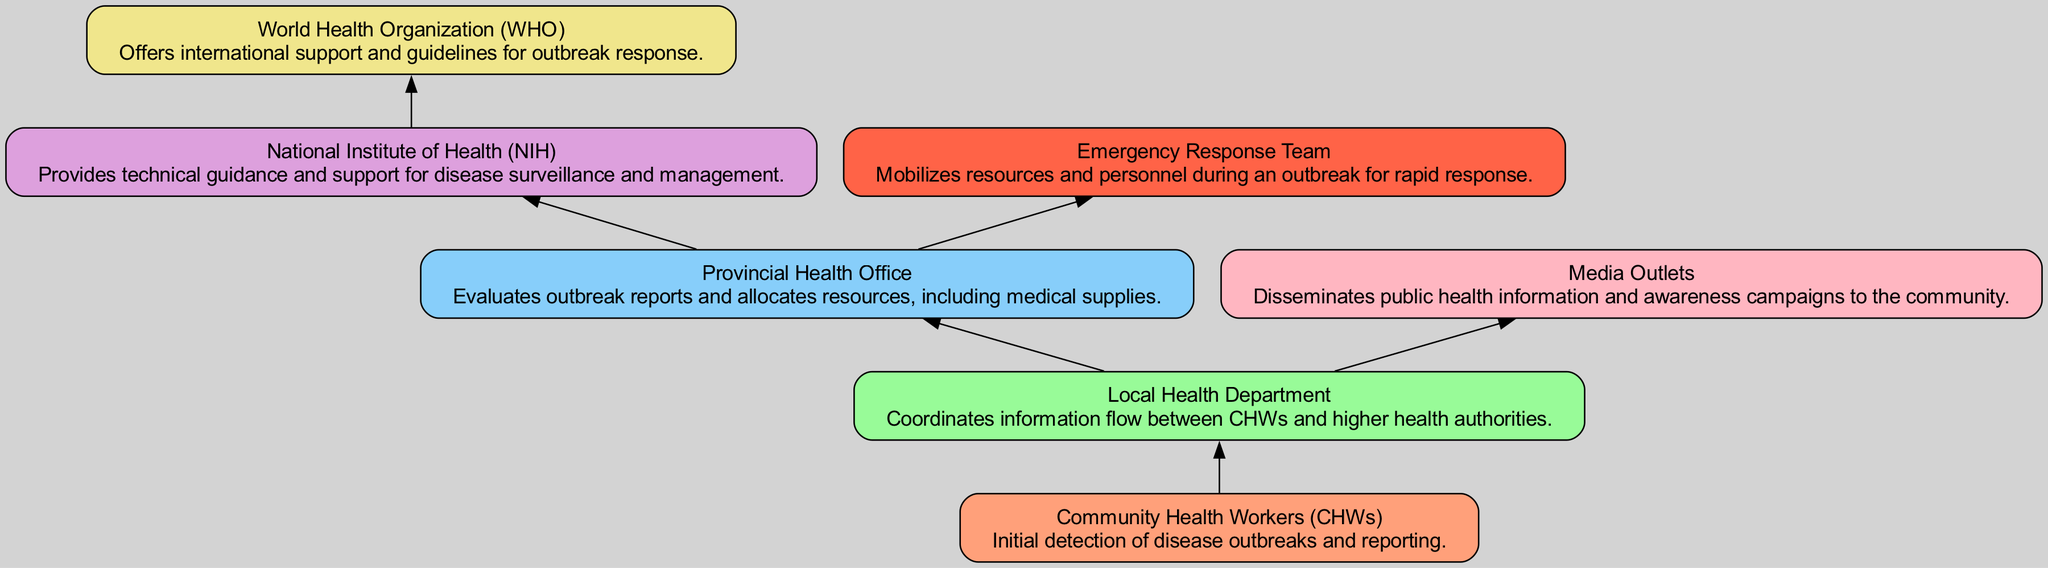What is the role of Community Health Workers (CHWs)? The diagram shows that Community Health Workers (CHWs) are responsible for the initial detection of disease outbreaks and reporting. Hence, their role is identified straightforwardly in their associated description.
Answer: Initial detection of disease outbreaks and reporting Which two entities are directly connected from the Local Health Department? According to the diagram, the Local Health Department has direct connections with the Provincial Health Office and Media Outlets. We can see these links explicitly drawn in the flow chart.
Answer: Provincial Health Office and Media Outlets How many total nodes are present in the diagram? The diagram contains a total of seven nodes, which are: Community Health Workers (CHWs), Local Health Department, Provincial Health Office, National Institute of Health (NIH), World Health Organization (WHO), Media Outlets, and Emergency Response Team. Thus, by counting these nodes, we arrive at the answer.
Answer: 7 What is the primary function of the Provincial Health Office? The Provincial Health Office’s role is to evaluate outbreak reports and allocate resources, including medical supplies, which is outlined clearly in the chart.
Answer: Evaluate outbreak reports and allocate resources, including medical supplies Who provides technical guidance and support for disease surveillance? The diagram indicates that the National Institute of Health (NIH) is responsible for providing technical guidance and support for disease surveillance and management. This is evident in the role label next to NIH.
Answer: National Institute of Health (NIH) Which entity mobilizes resources and personnel during an outbreak? The diagram specifies that the Emergency Response Team is tasked with mobilizing resources and personnel during an outbreak, as indicated in its role description.
Answer: Emergency Response Team What entity is responsible for disseminating public health information? Media Outlets are responsible for disseminating public health information and awareness campaigns to the community, a role clearly outlined in the diagram.
Answer: Media Outlets Which organization offers international support and guidelines for outbreak response? The World Health Organization (WHO) is highlighted in the chart as the entity that offers international support and guidelines for outbreak response. This is specifically stated in its designated role.
Answer: World Health Organization (WHO) What is the flow direction of communication from Local Health Department? The communication flow from the Local Health Department moves both upwards to the Provincial Health Office and upwards to the World Health Organization through the National Institute of Health. This shows a multi-directional flow emerging from a single node.
Answer: Upwards to Provincial Health Office and World Health Organization through National Institute of Health 